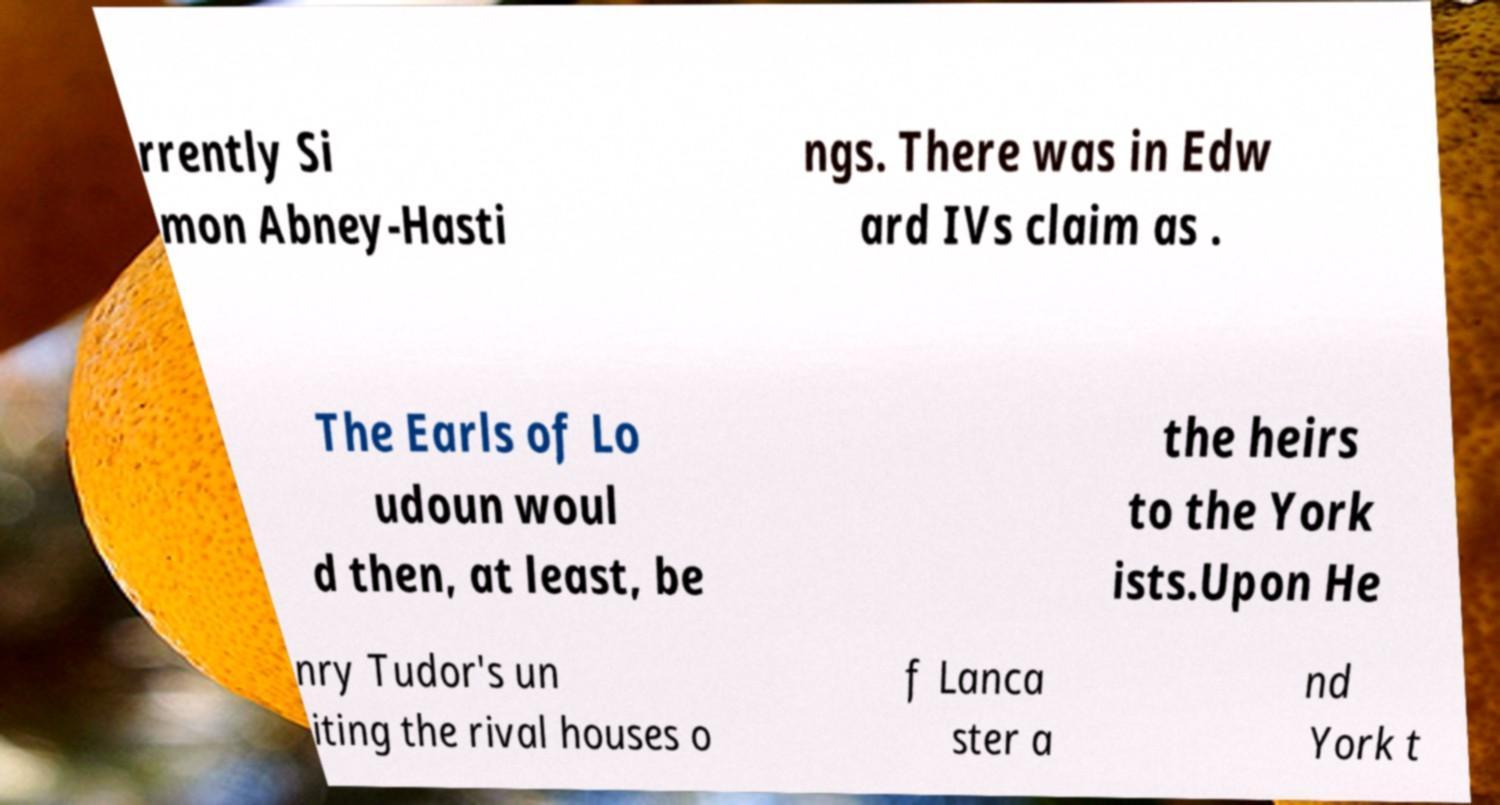There's text embedded in this image that I need extracted. Can you transcribe it verbatim? rrently Si mon Abney-Hasti ngs. There was in Edw ard IVs claim as . The Earls of Lo udoun woul d then, at least, be the heirs to the York ists.Upon He nry Tudor's un iting the rival houses o f Lanca ster a nd York t 